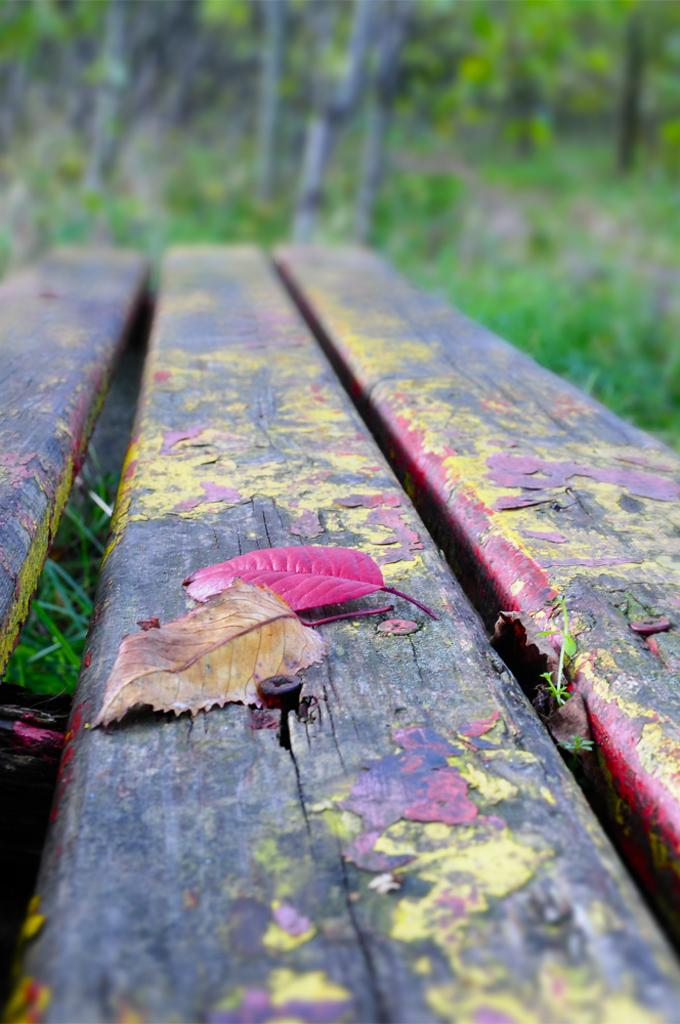What is on the bench in the image? There are leafs on the bench in the image. Can you describe the background of the image? The background of the image is blurred. What type of drink can be seen being poured in the image? There is no drink present in the image; it only features a bench with leafs and a blurred background. 